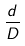<formula> <loc_0><loc_0><loc_500><loc_500>\frac { d } { D }</formula> 